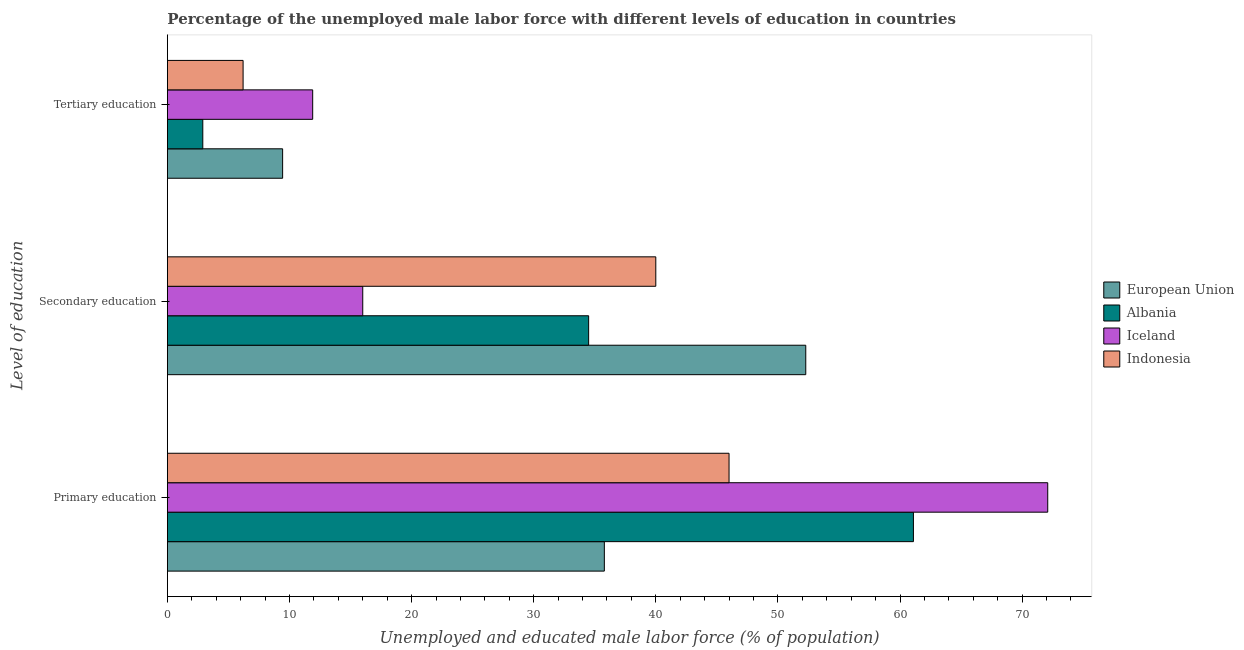How many different coloured bars are there?
Your answer should be very brief. 4. How many groups of bars are there?
Keep it short and to the point. 3. How many bars are there on the 1st tick from the top?
Provide a short and direct response. 4. How many bars are there on the 1st tick from the bottom?
Provide a short and direct response. 4. What is the label of the 1st group of bars from the top?
Keep it short and to the point. Tertiary education. What is the percentage of male labor force who received primary education in European Union?
Keep it short and to the point. 35.79. Across all countries, what is the maximum percentage of male labor force who received tertiary education?
Make the answer very short. 11.9. Across all countries, what is the minimum percentage of male labor force who received tertiary education?
Your answer should be very brief. 2.9. What is the total percentage of male labor force who received tertiary education in the graph?
Give a very brief answer. 30.44. What is the difference between the percentage of male labor force who received secondary education in Albania and that in European Union?
Give a very brief answer. -17.78. What is the difference between the percentage of male labor force who received secondary education in Iceland and the percentage of male labor force who received primary education in Albania?
Keep it short and to the point. -45.1. What is the average percentage of male labor force who received primary education per country?
Provide a succinct answer. 53.75. What is the difference between the percentage of male labor force who received secondary education and percentage of male labor force who received tertiary education in Albania?
Your answer should be compact. 31.6. In how many countries, is the percentage of male labor force who received tertiary education greater than 72 %?
Provide a succinct answer. 0. What is the ratio of the percentage of male labor force who received primary education in European Union to that in Indonesia?
Provide a short and direct response. 0.78. Is the percentage of male labor force who received secondary education in Albania less than that in European Union?
Your answer should be compact. Yes. Is the difference between the percentage of male labor force who received tertiary education in Albania and European Union greater than the difference between the percentage of male labor force who received secondary education in Albania and European Union?
Provide a succinct answer. Yes. What is the difference between the highest and the second highest percentage of male labor force who received primary education?
Your response must be concise. 11. What is the difference between the highest and the lowest percentage of male labor force who received secondary education?
Provide a short and direct response. 36.28. In how many countries, is the percentage of male labor force who received secondary education greater than the average percentage of male labor force who received secondary education taken over all countries?
Ensure brevity in your answer.  2. Is the sum of the percentage of male labor force who received tertiary education in Indonesia and European Union greater than the maximum percentage of male labor force who received primary education across all countries?
Make the answer very short. No. What does the 3rd bar from the top in Primary education represents?
Provide a short and direct response. Albania. What does the 2nd bar from the bottom in Tertiary education represents?
Ensure brevity in your answer.  Albania. Are all the bars in the graph horizontal?
Offer a terse response. Yes. Where does the legend appear in the graph?
Make the answer very short. Center right. How many legend labels are there?
Your answer should be compact. 4. What is the title of the graph?
Give a very brief answer. Percentage of the unemployed male labor force with different levels of education in countries. Does "Iran" appear as one of the legend labels in the graph?
Provide a short and direct response. No. What is the label or title of the X-axis?
Provide a succinct answer. Unemployed and educated male labor force (% of population). What is the label or title of the Y-axis?
Provide a short and direct response. Level of education. What is the Unemployed and educated male labor force (% of population) of European Union in Primary education?
Keep it short and to the point. 35.79. What is the Unemployed and educated male labor force (% of population) of Albania in Primary education?
Provide a short and direct response. 61.1. What is the Unemployed and educated male labor force (% of population) in Iceland in Primary education?
Ensure brevity in your answer.  72.1. What is the Unemployed and educated male labor force (% of population) of European Union in Secondary education?
Offer a very short reply. 52.28. What is the Unemployed and educated male labor force (% of population) of Albania in Secondary education?
Keep it short and to the point. 34.5. What is the Unemployed and educated male labor force (% of population) in Iceland in Secondary education?
Offer a very short reply. 16. What is the Unemployed and educated male labor force (% of population) in European Union in Tertiary education?
Your response must be concise. 9.44. What is the Unemployed and educated male labor force (% of population) of Albania in Tertiary education?
Make the answer very short. 2.9. What is the Unemployed and educated male labor force (% of population) of Iceland in Tertiary education?
Offer a terse response. 11.9. What is the Unemployed and educated male labor force (% of population) of Indonesia in Tertiary education?
Give a very brief answer. 6.2. Across all Level of education, what is the maximum Unemployed and educated male labor force (% of population) of European Union?
Make the answer very short. 52.28. Across all Level of education, what is the maximum Unemployed and educated male labor force (% of population) in Albania?
Ensure brevity in your answer.  61.1. Across all Level of education, what is the maximum Unemployed and educated male labor force (% of population) of Iceland?
Keep it short and to the point. 72.1. Across all Level of education, what is the maximum Unemployed and educated male labor force (% of population) in Indonesia?
Provide a short and direct response. 46. Across all Level of education, what is the minimum Unemployed and educated male labor force (% of population) of European Union?
Your response must be concise. 9.44. Across all Level of education, what is the minimum Unemployed and educated male labor force (% of population) of Albania?
Your response must be concise. 2.9. Across all Level of education, what is the minimum Unemployed and educated male labor force (% of population) of Iceland?
Give a very brief answer. 11.9. Across all Level of education, what is the minimum Unemployed and educated male labor force (% of population) in Indonesia?
Your response must be concise. 6.2. What is the total Unemployed and educated male labor force (% of population) of European Union in the graph?
Provide a short and direct response. 97.51. What is the total Unemployed and educated male labor force (% of population) of Albania in the graph?
Offer a terse response. 98.5. What is the total Unemployed and educated male labor force (% of population) in Indonesia in the graph?
Provide a short and direct response. 92.2. What is the difference between the Unemployed and educated male labor force (% of population) in European Union in Primary education and that in Secondary education?
Make the answer very short. -16.5. What is the difference between the Unemployed and educated male labor force (% of population) in Albania in Primary education and that in Secondary education?
Offer a terse response. 26.6. What is the difference between the Unemployed and educated male labor force (% of population) of Iceland in Primary education and that in Secondary education?
Provide a succinct answer. 56.1. What is the difference between the Unemployed and educated male labor force (% of population) of European Union in Primary education and that in Tertiary education?
Offer a terse response. 26.35. What is the difference between the Unemployed and educated male labor force (% of population) in Albania in Primary education and that in Tertiary education?
Provide a short and direct response. 58.2. What is the difference between the Unemployed and educated male labor force (% of population) in Iceland in Primary education and that in Tertiary education?
Your answer should be very brief. 60.2. What is the difference between the Unemployed and educated male labor force (% of population) in Indonesia in Primary education and that in Tertiary education?
Offer a very short reply. 39.8. What is the difference between the Unemployed and educated male labor force (% of population) in European Union in Secondary education and that in Tertiary education?
Make the answer very short. 42.85. What is the difference between the Unemployed and educated male labor force (% of population) in Albania in Secondary education and that in Tertiary education?
Make the answer very short. 31.6. What is the difference between the Unemployed and educated male labor force (% of population) of Indonesia in Secondary education and that in Tertiary education?
Offer a terse response. 33.8. What is the difference between the Unemployed and educated male labor force (% of population) of European Union in Primary education and the Unemployed and educated male labor force (% of population) of Albania in Secondary education?
Ensure brevity in your answer.  1.29. What is the difference between the Unemployed and educated male labor force (% of population) in European Union in Primary education and the Unemployed and educated male labor force (% of population) in Iceland in Secondary education?
Provide a succinct answer. 19.79. What is the difference between the Unemployed and educated male labor force (% of population) of European Union in Primary education and the Unemployed and educated male labor force (% of population) of Indonesia in Secondary education?
Your answer should be compact. -4.21. What is the difference between the Unemployed and educated male labor force (% of population) of Albania in Primary education and the Unemployed and educated male labor force (% of population) of Iceland in Secondary education?
Your answer should be compact. 45.1. What is the difference between the Unemployed and educated male labor force (% of population) in Albania in Primary education and the Unemployed and educated male labor force (% of population) in Indonesia in Secondary education?
Provide a succinct answer. 21.1. What is the difference between the Unemployed and educated male labor force (% of population) in Iceland in Primary education and the Unemployed and educated male labor force (% of population) in Indonesia in Secondary education?
Give a very brief answer. 32.1. What is the difference between the Unemployed and educated male labor force (% of population) of European Union in Primary education and the Unemployed and educated male labor force (% of population) of Albania in Tertiary education?
Give a very brief answer. 32.89. What is the difference between the Unemployed and educated male labor force (% of population) in European Union in Primary education and the Unemployed and educated male labor force (% of population) in Iceland in Tertiary education?
Your response must be concise. 23.89. What is the difference between the Unemployed and educated male labor force (% of population) in European Union in Primary education and the Unemployed and educated male labor force (% of population) in Indonesia in Tertiary education?
Ensure brevity in your answer.  29.59. What is the difference between the Unemployed and educated male labor force (% of population) of Albania in Primary education and the Unemployed and educated male labor force (% of population) of Iceland in Tertiary education?
Offer a terse response. 49.2. What is the difference between the Unemployed and educated male labor force (% of population) of Albania in Primary education and the Unemployed and educated male labor force (% of population) of Indonesia in Tertiary education?
Offer a very short reply. 54.9. What is the difference between the Unemployed and educated male labor force (% of population) of Iceland in Primary education and the Unemployed and educated male labor force (% of population) of Indonesia in Tertiary education?
Give a very brief answer. 65.9. What is the difference between the Unemployed and educated male labor force (% of population) in European Union in Secondary education and the Unemployed and educated male labor force (% of population) in Albania in Tertiary education?
Give a very brief answer. 49.38. What is the difference between the Unemployed and educated male labor force (% of population) in European Union in Secondary education and the Unemployed and educated male labor force (% of population) in Iceland in Tertiary education?
Provide a short and direct response. 40.38. What is the difference between the Unemployed and educated male labor force (% of population) of European Union in Secondary education and the Unemployed and educated male labor force (% of population) of Indonesia in Tertiary education?
Ensure brevity in your answer.  46.08. What is the difference between the Unemployed and educated male labor force (% of population) of Albania in Secondary education and the Unemployed and educated male labor force (% of population) of Iceland in Tertiary education?
Make the answer very short. 22.6. What is the difference between the Unemployed and educated male labor force (% of population) in Albania in Secondary education and the Unemployed and educated male labor force (% of population) in Indonesia in Tertiary education?
Provide a succinct answer. 28.3. What is the difference between the Unemployed and educated male labor force (% of population) in Iceland in Secondary education and the Unemployed and educated male labor force (% of population) in Indonesia in Tertiary education?
Your answer should be compact. 9.8. What is the average Unemployed and educated male labor force (% of population) in European Union per Level of education?
Your answer should be very brief. 32.5. What is the average Unemployed and educated male labor force (% of population) of Albania per Level of education?
Your response must be concise. 32.83. What is the average Unemployed and educated male labor force (% of population) in Iceland per Level of education?
Provide a succinct answer. 33.33. What is the average Unemployed and educated male labor force (% of population) in Indonesia per Level of education?
Offer a terse response. 30.73. What is the difference between the Unemployed and educated male labor force (% of population) in European Union and Unemployed and educated male labor force (% of population) in Albania in Primary education?
Make the answer very short. -25.31. What is the difference between the Unemployed and educated male labor force (% of population) of European Union and Unemployed and educated male labor force (% of population) of Iceland in Primary education?
Offer a very short reply. -36.31. What is the difference between the Unemployed and educated male labor force (% of population) in European Union and Unemployed and educated male labor force (% of population) in Indonesia in Primary education?
Keep it short and to the point. -10.21. What is the difference between the Unemployed and educated male labor force (% of population) of Albania and Unemployed and educated male labor force (% of population) of Indonesia in Primary education?
Ensure brevity in your answer.  15.1. What is the difference between the Unemployed and educated male labor force (% of population) of Iceland and Unemployed and educated male labor force (% of population) of Indonesia in Primary education?
Your answer should be compact. 26.1. What is the difference between the Unemployed and educated male labor force (% of population) of European Union and Unemployed and educated male labor force (% of population) of Albania in Secondary education?
Your response must be concise. 17.78. What is the difference between the Unemployed and educated male labor force (% of population) in European Union and Unemployed and educated male labor force (% of population) in Iceland in Secondary education?
Provide a succinct answer. 36.28. What is the difference between the Unemployed and educated male labor force (% of population) of European Union and Unemployed and educated male labor force (% of population) of Indonesia in Secondary education?
Provide a short and direct response. 12.28. What is the difference between the Unemployed and educated male labor force (% of population) of Albania and Unemployed and educated male labor force (% of population) of Iceland in Secondary education?
Keep it short and to the point. 18.5. What is the difference between the Unemployed and educated male labor force (% of population) in Albania and Unemployed and educated male labor force (% of population) in Indonesia in Secondary education?
Offer a terse response. -5.5. What is the difference between the Unemployed and educated male labor force (% of population) of Iceland and Unemployed and educated male labor force (% of population) of Indonesia in Secondary education?
Ensure brevity in your answer.  -24. What is the difference between the Unemployed and educated male labor force (% of population) of European Union and Unemployed and educated male labor force (% of population) of Albania in Tertiary education?
Offer a terse response. 6.54. What is the difference between the Unemployed and educated male labor force (% of population) of European Union and Unemployed and educated male labor force (% of population) of Iceland in Tertiary education?
Provide a short and direct response. -2.46. What is the difference between the Unemployed and educated male labor force (% of population) of European Union and Unemployed and educated male labor force (% of population) of Indonesia in Tertiary education?
Keep it short and to the point. 3.24. What is the difference between the Unemployed and educated male labor force (% of population) of Albania and Unemployed and educated male labor force (% of population) of Iceland in Tertiary education?
Offer a terse response. -9. What is the ratio of the Unemployed and educated male labor force (% of population) of European Union in Primary education to that in Secondary education?
Provide a short and direct response. 0.68. What is the ratio of the Unemployed and educated male labor force (% of population) of Albania in Primary education to that in Secondary education?
Provide a succinct answer. 1.77. What is the ratio of the Unemployed and educated male labor force (% of population) in Iceland in Primary education to that in Secondary education?
Offer a terse response. 4.51. What is the ratio of the Unemployed and educated male labor force (% of population) of Indonesia in Primary education to that in Secondary education?
Provide a succinct answer. 1.15. What is the ratio of the Unemployed and educated male labor force (% of population) in European Union in Primary education to that in Tertiary education?
Provide a short and direct response. 3.79. What is the ratio of the Unemployed and educated male labor force (% of population) of Albania in Primary education to that in Tertiary education?
Your response must be concise. 21.07. What is the ratio of the Unemployed and educated male labor force (% of population) in Iceland in Primary education to that in Tertiary education?
Give a very brief answer. 6.06. What is the ratio of the Unemployed and educated male labor force (% of population) of Indonesia in Primary education to that in Tertiary education?
Provide a succinct answer. 7.42. What is the ratio of the Unemployed and educated male labor force (% of population) in European Union in Secondary education to that in Tertiary education?
Offer a terse response. 5.54. What is the ratio of the Unemployed and educated male labor force (% of population) of Albania in Secondary education to that in Tertiary education?
Offer a very short reply. 11.9. What is the ratio of the Unemployed and educated male labor force (% of population) in Iceland in Secondary education to that in Tertiary education?
Give a very brief answer. 1.34. What is the ratio of the Unemployed and educated male labor force (% of population) of Indonesia in Secondary education to that in Tertiary education?
Keep it short and to the point. 6.45. What is the difference between the highest and the second highest Unemployed and educated male labor force (% of population) of European Union?
Your answer should be compact. 16.5. What is the difference between the highest and the second highest Unemployed and educated male labor force (% of population) of Albania?
Provide a succinct answer. 26.6. What is the difference between the highest and the second highest Unemployed and educated male labor force (% of population) in Iceland?
Your answer should be very brief. 56.1. What is the difference between the highest and the lowest Unemployed and educated male labor force (% of population) of European Union?
Ensure brevity in your answer.  42.85. What is the difference between the highest and the lowest Unemployed and educated male labor force (% of population) of Albania?
Your answer should be compact. 58.2. What is the difference between the highest and the lowest Unemployed and educated male labor force (% of population) in Iceland?
Keep it short and to the point. 60.2. What is the difference between the highest and the lowest Unemployed and educated male labor force (% of population) of Indonesia?
Your answer should be compact. 39.8. 